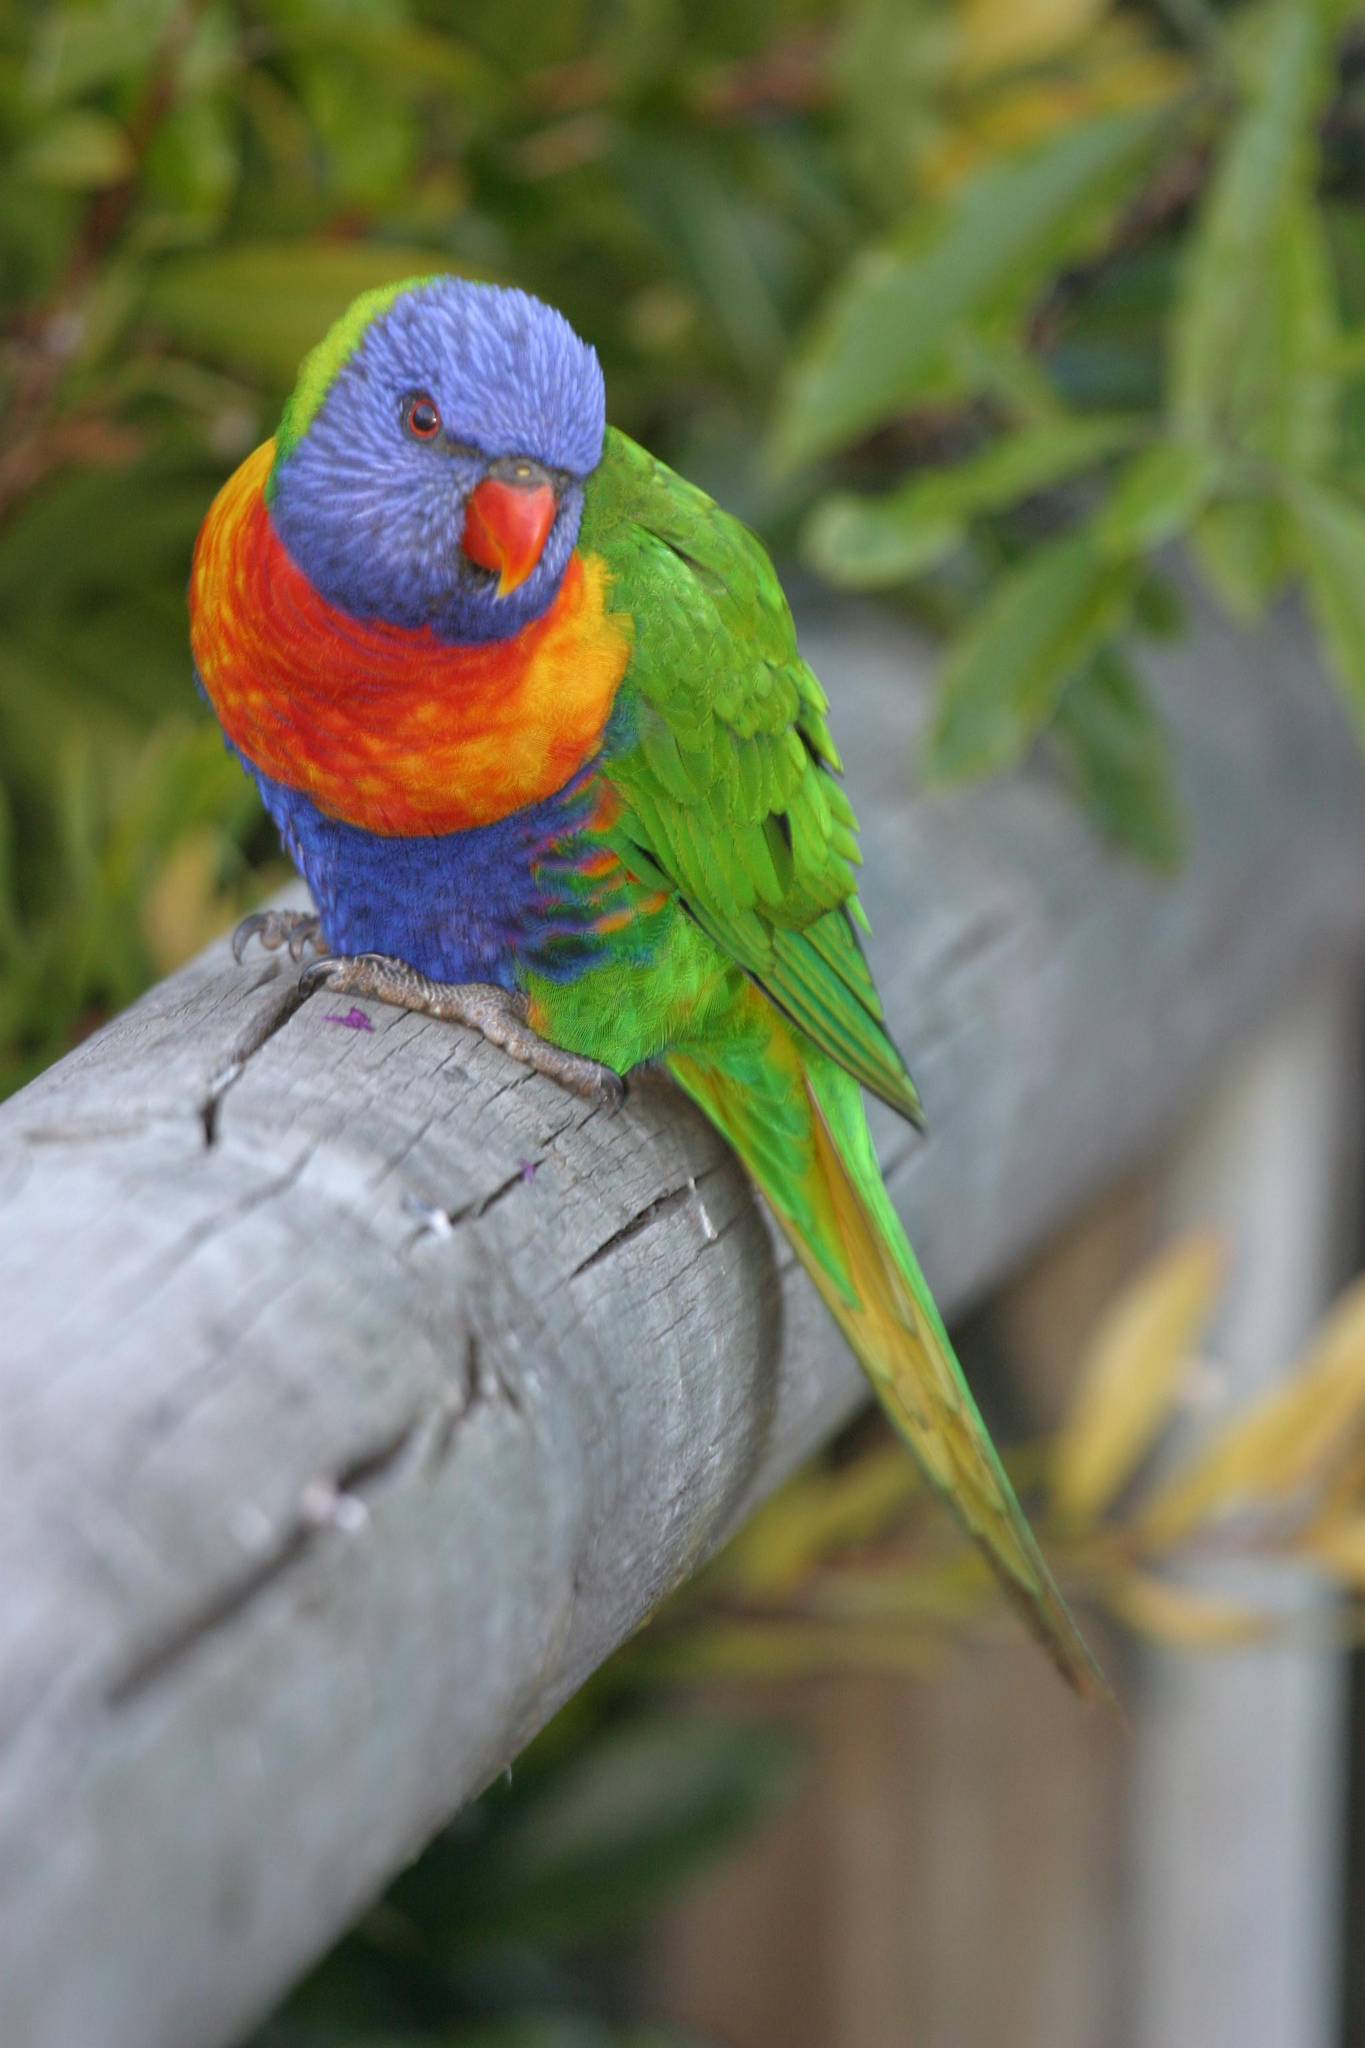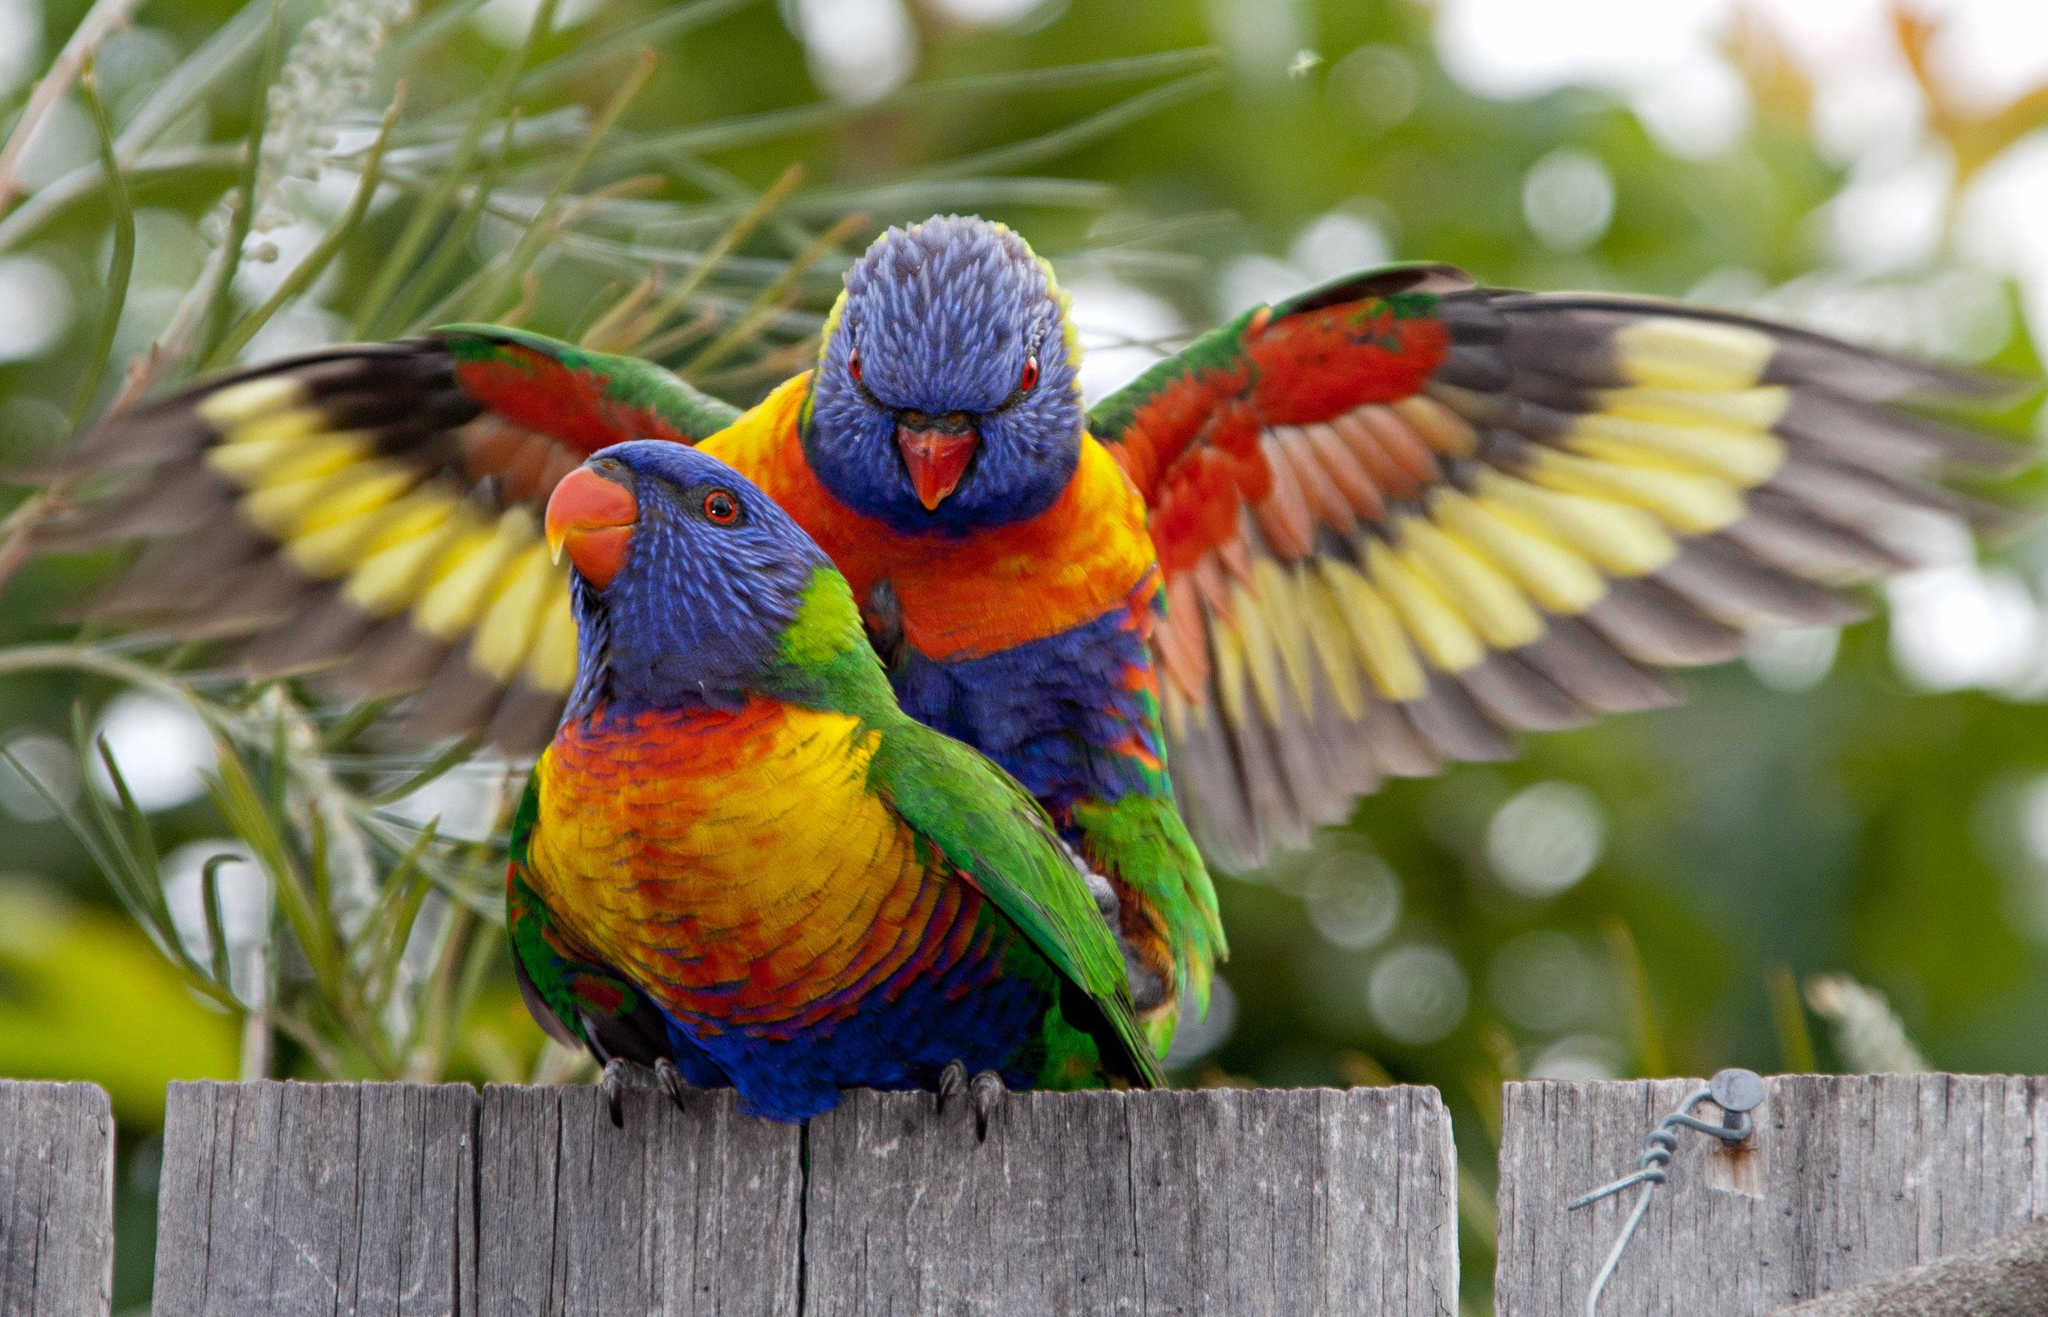The first image is the image on the left, the second image is the image on the right. For the images displayed, is the sentence "Two birds are perched together in at least one of the images." factually correct? Answer yes or no. Yes. 